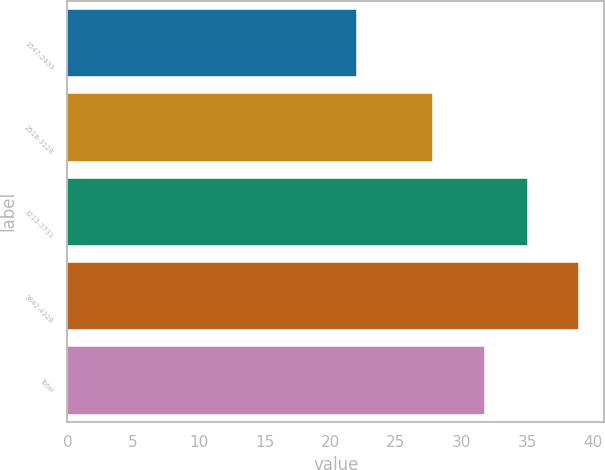Convert chart. <chart><loc_0><loc_0><loc_500><loc_500><bar_chart><fcel>1547-2433<fcel>2518-3128<fcel>3213-3731<fcel>3842-4328<fcel>Total<nl><fcel>21.95<fcel>27.72<fcel>34.97<fcel>38.9<fcel>31.69<nl></chart> 